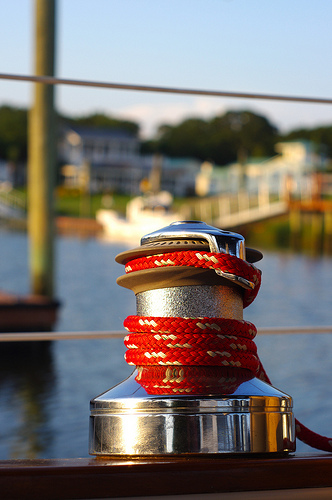<image>
Can you confirm if the pole is to the left of the chord? Yes. From this viewpoint, the pole is positioned to the left side relative to the chord. 